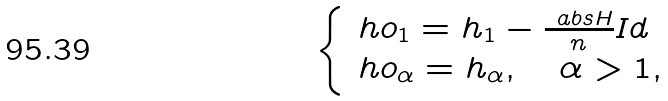Convert formula to latex. <formula><loc_0><loc_0><loc_500><loc_500>\begin{cases} \ h o { _ { 1 } } = h _ { 1 } - \frac { \ a b s { H } } { n } I d \\ \ h o _ { \alpha } = h _ { \alpha } , \quad \alpha > 1 , \end{cases}</formula> 